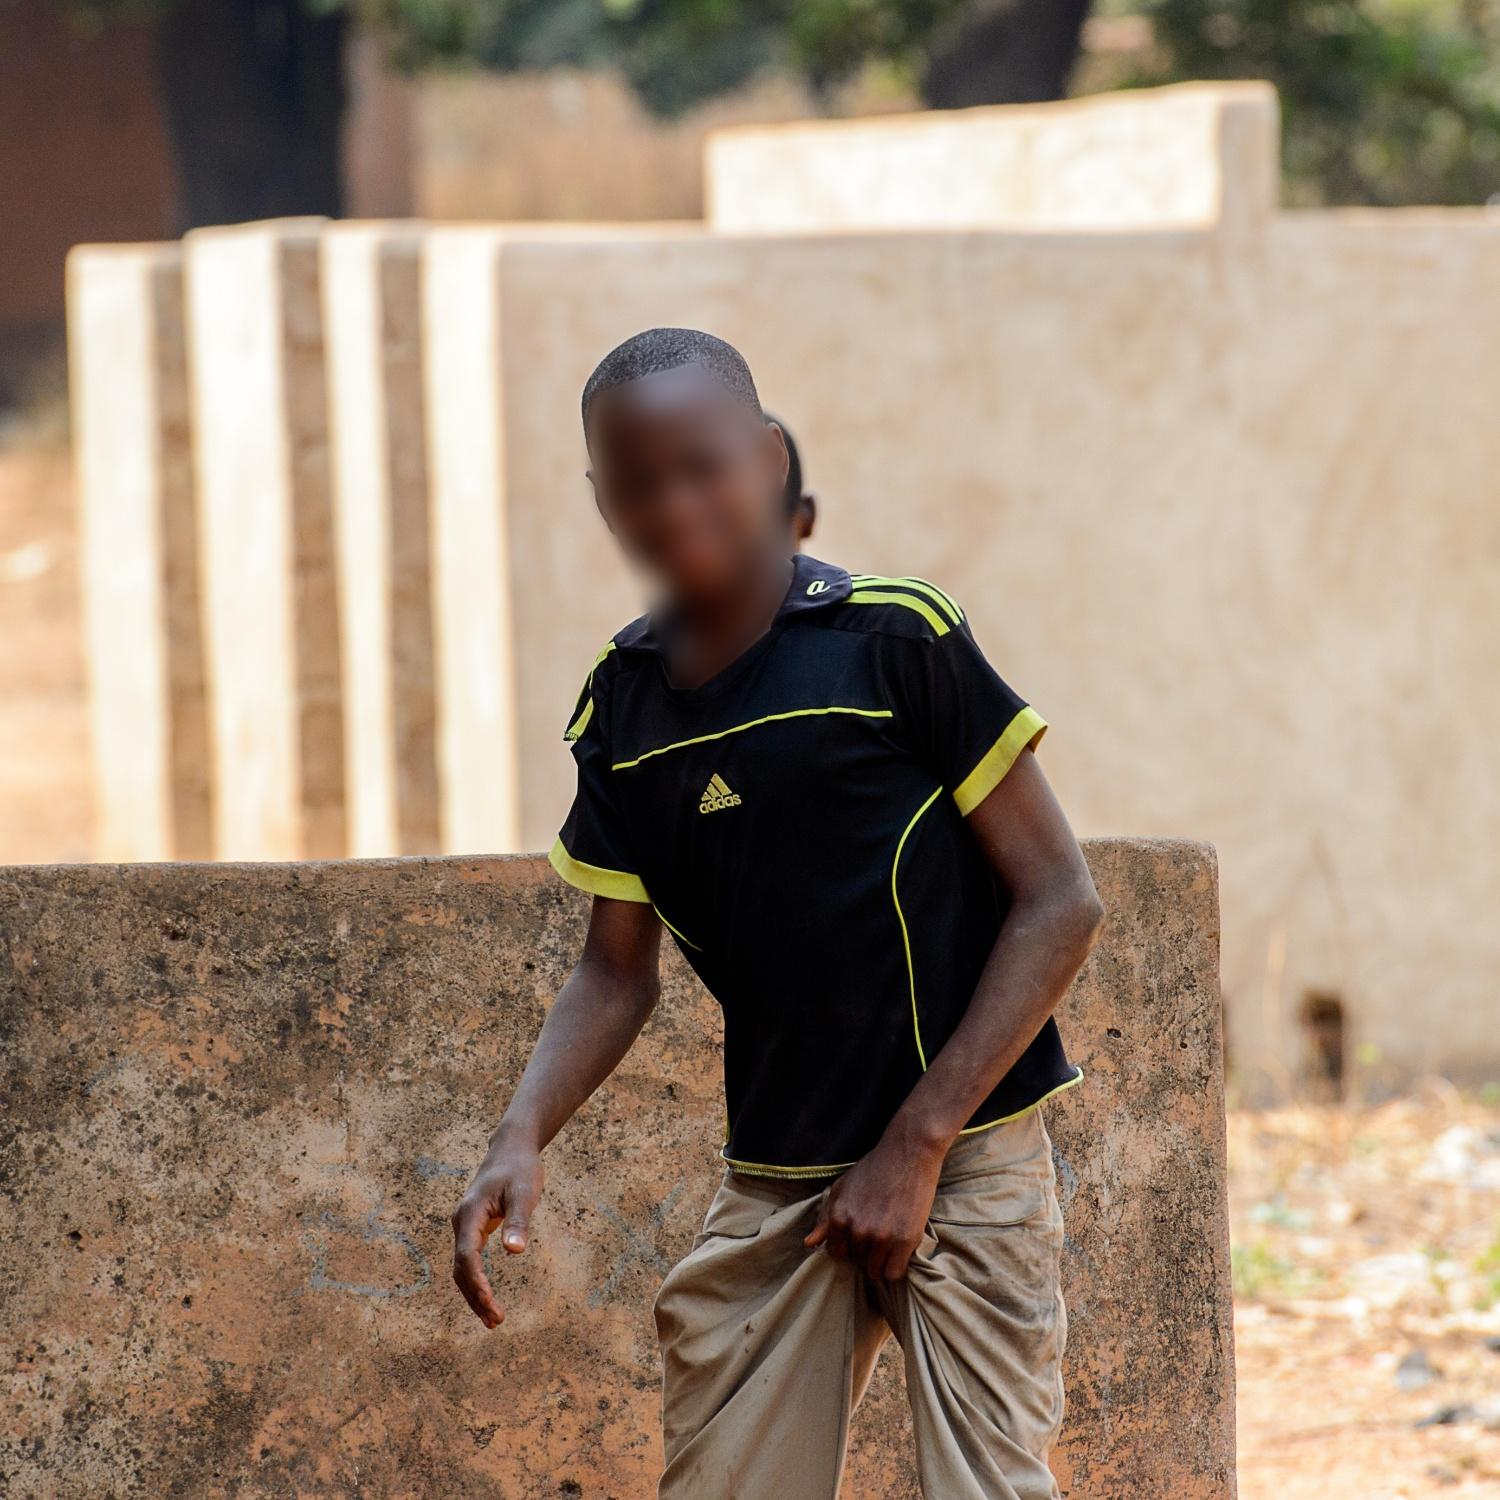Write a detailed description of the given image. In the image, a young boy is the focal point. He is standing against a weathered concrete wall, which appears to be part of a series of walls structured in a staggered layout in the background. The boy is wearing a black and yellow Adidas sport shirt that stands out vividly against the neutral tones of the surrounding environment. His trousers are sandy-colored, suggesting interaction with the earthy outdoors. The setting is an open dirt area, reinforced by the presence of natural elements such as trees seen behind the walls. For privacy reasons, the boy's facial features are blurred, preserving his anonymity. His posture indicates a relaxed and casual stance as he leans on one hand against the wall, with his legs slightly bent. The background includes both natural elements and man-made structures, offering a mix of rugged, earthy textures and the simplicity of the concrete walls. 